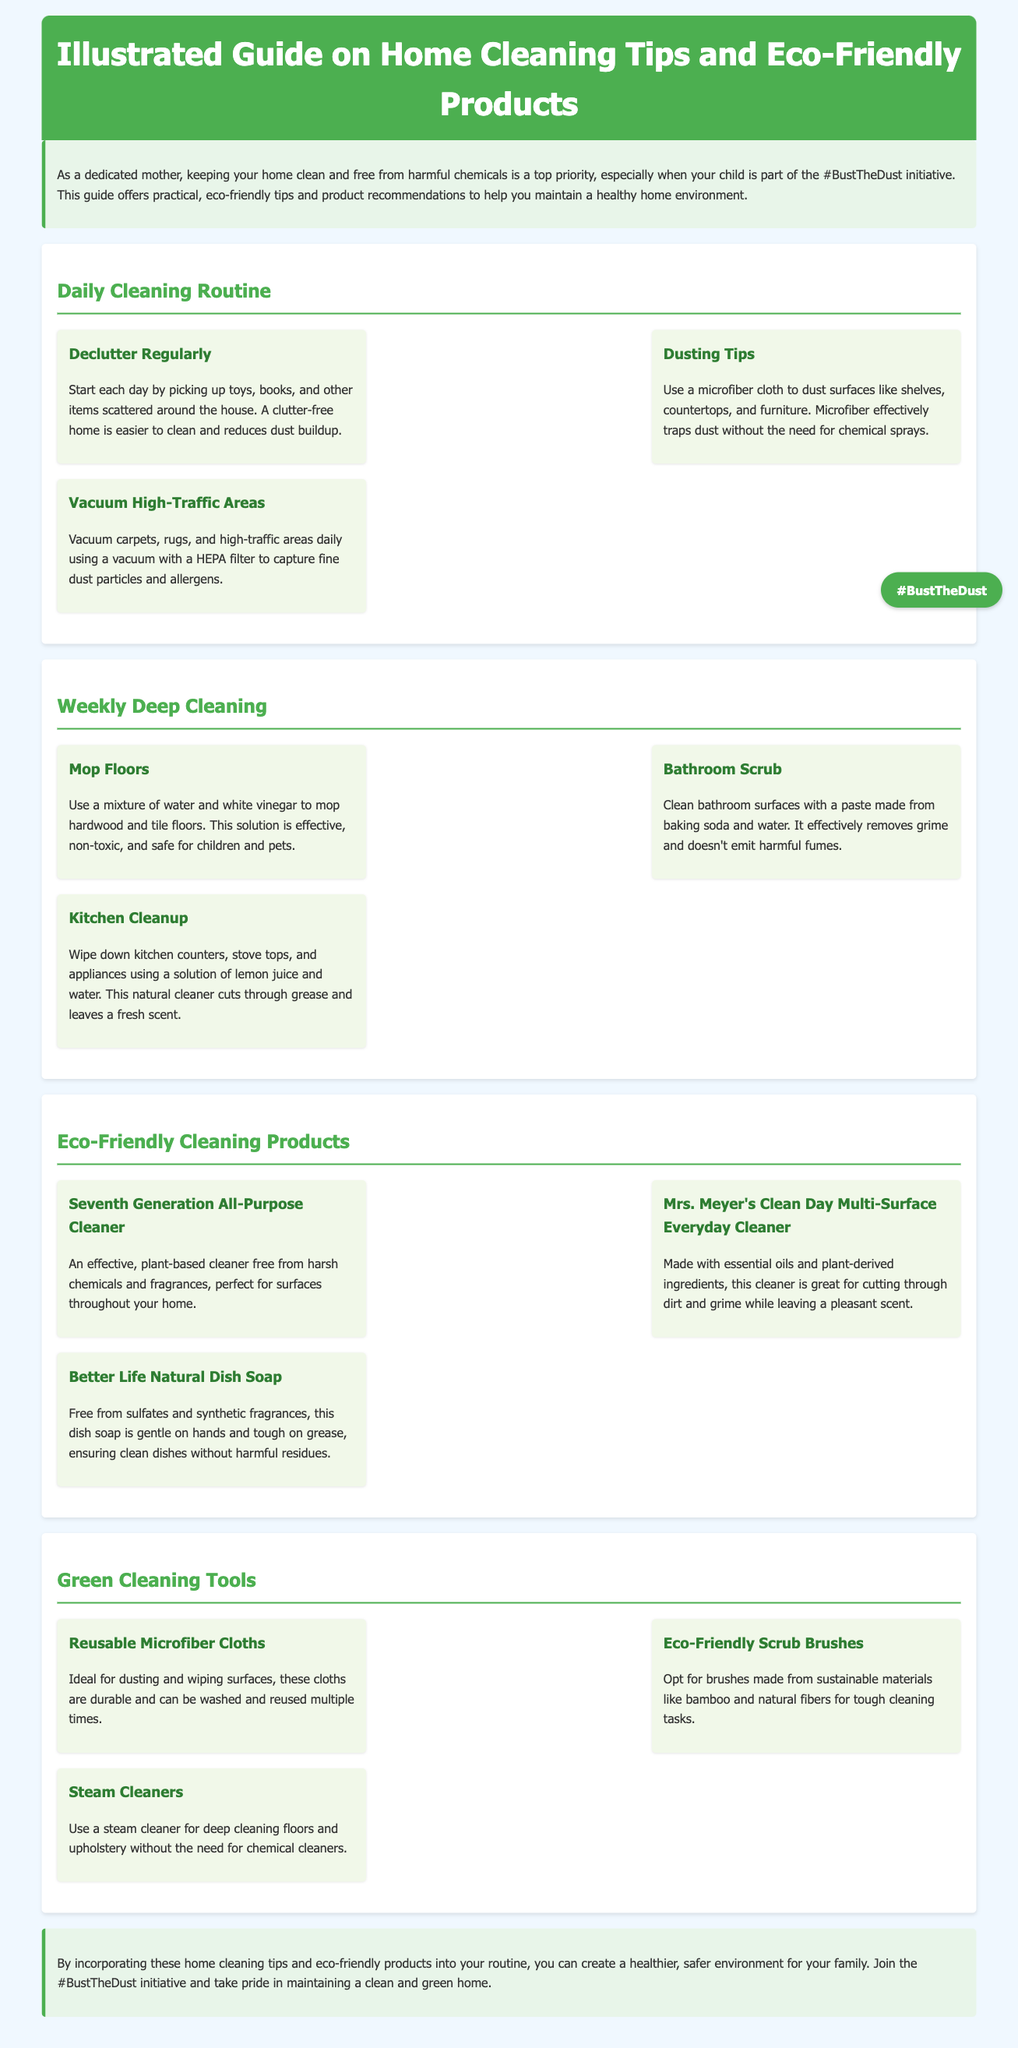What is the title of the document? The title is specified in the header of the document, which is "Illustrated Guide on Home Cleaning Tips and Eco-Friendly Products."
Answer: Illustrated Guide on Home Cleaning Tips and Eco-Friendly Products What section discusses cleaning the bathroom? The section that deals with cleaning the bathroom is titled "Weekly Deep Cleaning," specifically highlighting the bathroom cleaning method.
Answer: Weekly Deep Cleaning How many eco-friendly cleaning products are listed? The document lists three eco-friendly cleaning products in the "Eco-Friendly Cleaning Products" section.
Answer: Three What natural ingredient is used for mopping floors? The document mentions using a mixture of water and white vinegar for mopping floors, providing an eco-friendly cleaning solution.
Answer: White vinegar Which cleaning tool is recommended for dusting? The guide recommends using reusable microfiber cloths for dusting, emphasizing their effectiveness and durability.
Answer: Reusable microfiber cloths What type of vacuum is suggested for capturing dust? The document suggests using a vacuum with a HEPA filter for vacuuming high-traffic areas during the daily cleaning routine.
Answer: HEPA filter What is the primary benefit of using a steam cleaner? The steam cleaner is highlighted for its ability to clean deeply without the need for chemical cleaners, aligning with eco-friendly practices.
Answer: Chemical-free cleaning What is the focus of the #BustTheDust initiative? The #BustTheDust initiative is about maintaining a clean and green home environment, especially for families.
Answer: Clean and green home What is the recommended paste for cleaning bathroom surfaces? The document recommends using a paste made from baking soda and water for cleaning bathroom surfaces effectively and safely.
Answer: Baking soda and water paste 